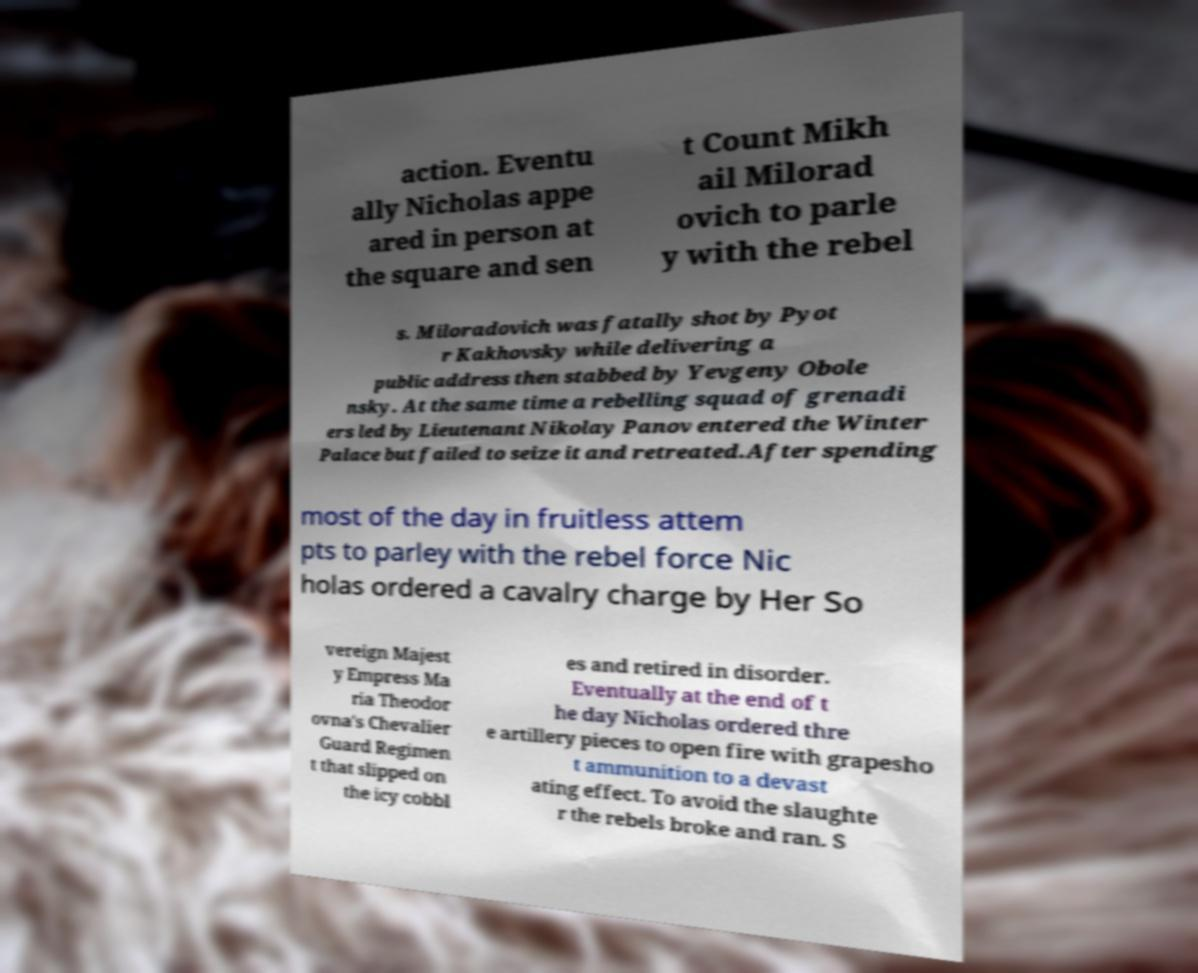What messages or text are displayed in this image? I need them in a readable, typed format. action. Eventu ally Nicholas appe ared in person at the square and sen t Count Mikh ail Milorad ovich to parle y with the rebel s. Miloradovich was fatally shot by Pyot r Kakhovsky while delivering a public address then stabbed by Yevgeny Obole nsky. At the same time a rebelling squad of grenadi ers led by Lieutenant Nikolay Panov entered the Winter Palace but failed to seize it and retreated.After spending most of the day in fruitless attem pts to parley with the rebel force Nic holas ordered a cavalry charge by Her So vereign Majest y Empress Ma ria Theodor ovna's Chevalier Guard Regimen t that slipped on the icy cobbl es and retired in disorder. Eventually at the end of t he day Nicholas ordered thre e artillery pieces to open fire with grapesho t ammunition to a devast ating effect. To avoid the slaughte r the rebels broke and ran. S 